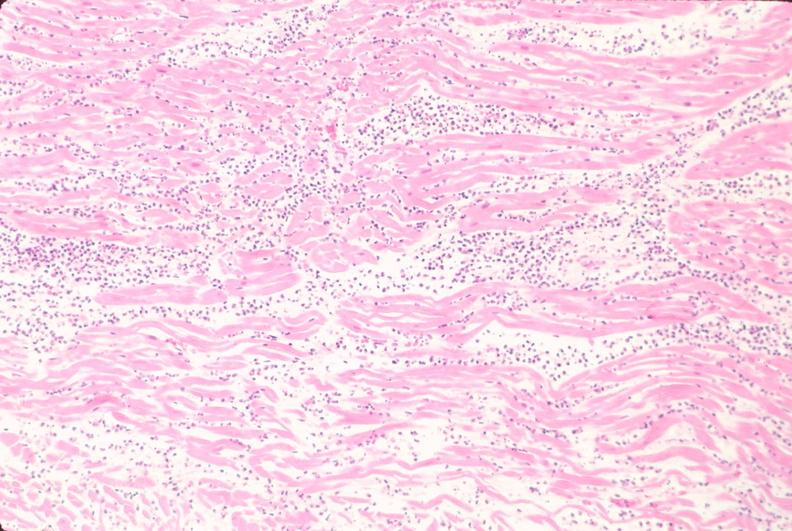s cardiovascular present?
Answer the question using a single word or phrase. Yes 